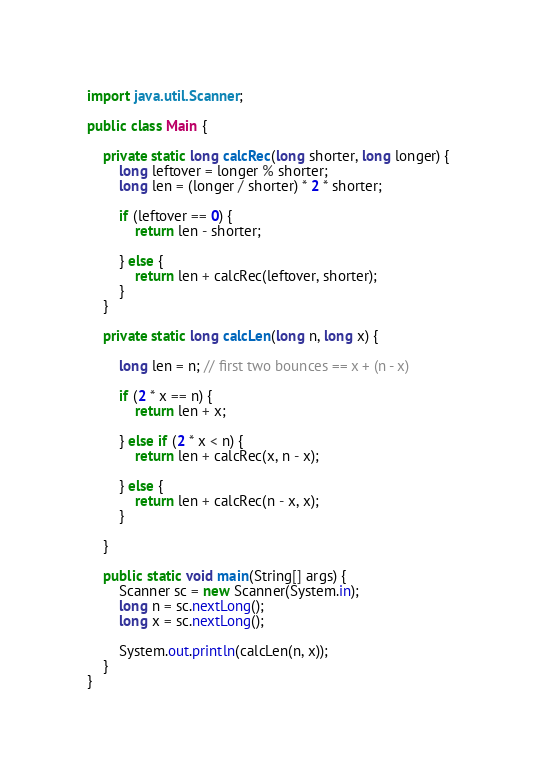Convert code to text. <code><loc_0><loc_0><loc_500><loc_500><_Java_>import java.util.Scanner;

public class Main {

    private static long calcRec(long shorter, long longer) {
        long leftover = longer % shorter;
        long len = (longer / shorter) * 2 * shorter;

        if (leftover == 0) {
            return len - shorter;

        } else {
            return len + calcRec(leftover, shorter);
        }
    }

    private static long calcLen(long n, long x) {

        long len = n; // first two bounces == x + (n - x)

        if (2 * x == n) {
            return len + x;

        } else if (2 * x < n) {
            return len + calcRec(x, n - x);

        } else {
            return len + calcRec(n - x, x);
        }

    }

    public static void main(String[] args) {
        Scanner sc = new Scanner(System.in);
        long n = sc.nextLong();
        long x = sc.nextLong();

        System.out.println(calcLen(n, x));
    }
}
</code> 